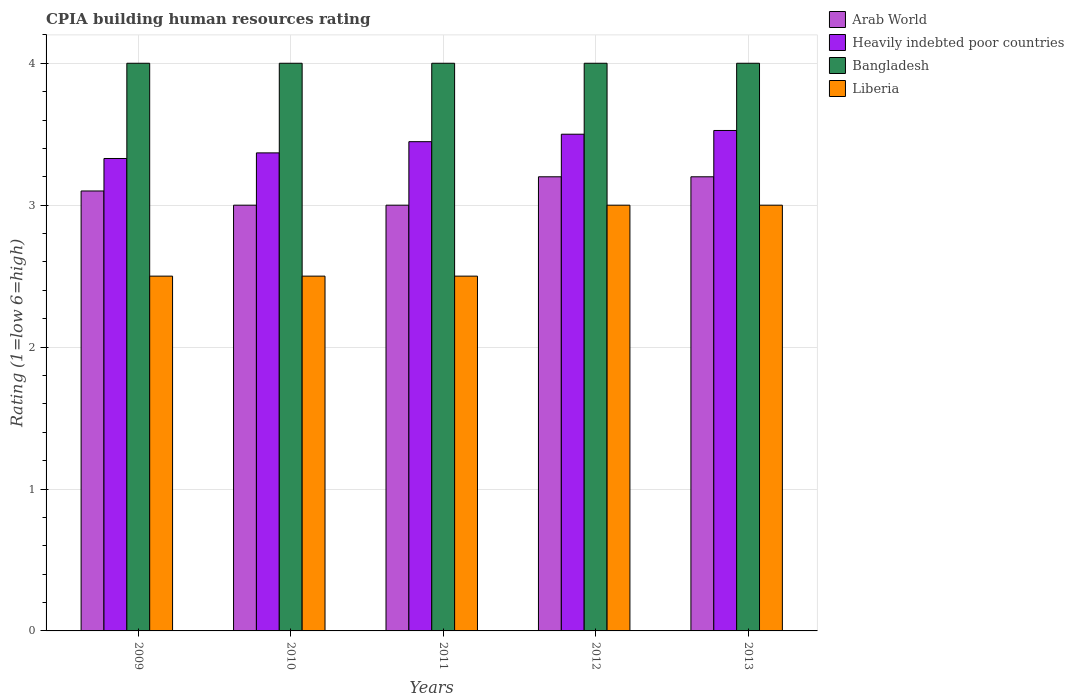How many different coloured bars are there?
Your response must be concise. 4. Are the number of bars per tick equal to the number of legend labels?
Provide a short and direct response. Yes. How many bars are there on the 2nd tick from the left?
Provide a short and direct response. 4. In how many cases, is the number of bars for a given year not equal to the number of legend labels?
Provide a short and direct response. 0. What is the CPIA rating in Bangladesh in 2013?
Ensure brevity in your answer.  4. Across all years, what is the maximum CPIA rating in Bangladesh?
Keep it short and to the point. 4. Across all years, what is the minimum CPIA rating in Heavily indebted poor countries?
Your answer should be very brief. 3.33. What is the total CPIA rating in Arab World in the graph?
Offer a very short reply. 15.5. What is the difference between the CPIA rating in Arab World in 2012 and the CPIA rating in Heavily indebted poor countries in 2013?
Offer a terse response. -0.33. In the year 2013, what is the difference between the CPIA rating in Arab World and CPIA rating in Heavily indebted poor countries?
Your answer should be very brief. -0.33. In how many years, is the CPIA rating in Liberia greater than 1.4?
Give a very brief answer. 5. What is the ratio of the CPIA rating in Heavily indebted poor countries in 2009 to that in 2013?
Your answer should be compact. 0.94. In how many years, is the CPIA rating in Arab World greater than the average CPIA rating in Arab World taken over all years?
Offer a very short reply. 2. Is the sum of the CPIA rating in Bangladesh in 2009 and 2011 greater than the maximum CPIA rating in Heavily indebted poor countries across all years?
Ensure brevity in your answer.  Yes. Is it the case that in every year, the sum of the CPIA rating in Heavily indebted poor countries and CPIA rating in Bangladesh is greater than the sum of CPIA rating in Liberia and CPIA rating in Arab World?
Provide a succinct answer. Yes. What does the 3rd bar from the right in 2012 represents?
Your response must be concise. Heavily indebted poor countries. Is it the case that in every year, the sum of the CPIA rating in Arab World and CPIA rating in Heavily indebted poor countries is greater than the CPIA rating in Liberia?
Make the answer very short. Yes. How many bars are there?
Offer a very short reply. 20. How many years are there in the graph?
Offer a terse response. 5. What is the difference between two consecutive major ticks on the Y-axis?
Give a very brief answer. 1. Are the values on the major ticks of Y-axis written in scientific E-notation?
Give a very brief answer. No. Does the graph contain grids?
Your answer should be compact. Yes. How many legend labels are there?
Offer a very short reply. 4. What is the title of the graph?
Keep it short and to the point. CPIA building human resources rating. Does "United Arab Emirates" appear as one of the legend labels in the graph?
Ensure brevity in your answer.  No. What is the label or title of the X-axis?
Your answer should be very brief. Years. What is the label or title of the Y-axis?
Your answer should be very brief. Rating (1=low 6=high). What is the Rating (1=low 6=high) in Heavily indebted poor countries in 2009?
Ensure brevity in your answer.  3.33. What is the Rating (1=low 6=high) in Arab World in 2010?
Your answer should be compact. 3. What is the Rating (1=low 6=high) of Heavily indebted poor countries in 2010?
Your answer should be very brief. 3.37. What is the Rating (1=low 6=high) of Heavily indebted poor countries in 2011?
Ensure brevity in your answer.  3.45. What is the Rating (1=low 6=high) of Liberia in 2011?
Keep it short and to the point. 2.5. What is the Rating (1=low 6=high) of Heavily indebted poor countries in 2012?
Your answer should be compact. 3.5. What is the Rating (1=low 6=high) of Liberia in 2012?
Your answer should be compact. 3. What is the Rating (1=low 6=high) in Heavily indebted poor countries in 2013?
Your answer should be very brief. 3.53. What is the Rating (1=low 6=high) of Bangladesh in 2013?
Provide a succinct answer. 4. What is the Rating (1=low 6=high) of Liberia in 2013?
Offer a very short reply. 3. Across all years, what is the maximum Rating (1=low 6=high) of Heavily indebted poor countries?
Ensure brevity in your answer.  3.53. Across all years, what is the maximum Rating (1=low 6=high) in Liberia?
Your response must be concise. 3. Across all years, what is the minimum Rating (1=low 6=high) in Arab World?
Give a very brief answer. 3. Across all years, what is the minimum Rating (1=low 6=high) of Heavily indebted poor countries?
Keep it short and to the point. 3.33. Across all years, what is the minimum Rating (1=low 6=high) of Bangladesh?
Your response must be concise. 4. What is the total Rating (1=low 6=high) in Arab World in the graph?
Ensure brevity in your answer.  15.5. What is the total Rating (1=low 6=high) in Heavily indebted poor countries in the graph?
Offer a very short reply. 17.17. What is the difference between the Rating (1=low 6=high) in Heavily indebted poor countries in 2009 and that in 2010?
Keep it short and to the point. -0.04. What is the difference between the Rating (1=low 6=high) of Liberia in 2009 and that in 2010?
Your answer should be compact. 0. What is the difference between the Rating (1=low 6=high) of Arab World in 2009 and that in 2011?
Your response must be concise. 0.1. What is the difference between the Rating (1=low 6=high) in Heavily indebted poor countries in 2009 and that in 2011?
Make the answer very short. -0.12. What is the difference between the Rating (1=low 6=high) of Arab World in 2009 and that in 2012?
Make the answer very short. -0.1. What is the difference between the Rating (1=low 6=high) of Heavily indebted poor countries in 2009 and that in 2012?
Ensure brevity in your answer.  -0.17. What is the difference between the Rating (1=low 6=high) of Bangladesh in 2009 and that in 2012?
Your response must be concise. 0. What is the difference between the Rating (1=low 6=high) in Liberia in 2009 and that in 2012?
Provide a short and direct response. -0.5. What is the difference between the Rating (1=low 6=high) of Arab World in 2009 and that in 2013?
Ensure brevity in your answer.  -0.1. What is the difference between the Rating (1=low 6=high) in Heavily indebted poor countries in 2009 and that in 2013?
Provide a succinct answer. -0.2. What is the difference between the Rating (1=low 6=high) of Liberia in 2009 and that in 2013?
Your response must be concise. -0.5. What is the difference between the Rating (1=low 6=high) in Heavily indebted poor countries in 2010 and that in 2011?
Offer a terse response. -0.08. What is the difference between the Rating (1=low 6=high) of Bangladesh in 2010 and that in 2011?
Keep it short and to the point. 0. What is the difference between the Rating (1=low 6=high) of Arab World in 2010 and that in 2012?
Your response must be concise. -0.2. What is the difference between the Rating (1=low 6=high) of Heavily indebted poor countries in 2010 and that in 2012?
Your answer should be very brief. -0.13. What is the difference between the Rating (1=low 6=high) of Bangladesh in 2010 and that in 2012?
Keep it short and to the point. 0. What is the difference between the Rating (1=low 6=high) of Liberia in 2010 and that in 2012?
Your response must be concise. -0.5. What is the difference between the Rating (1=low 6=high) of Heavily indebted poor countries in 2010 and that in 2013?
Ensure brevity in your answer.  -0.16. What is the difference between the Rating (1=low 6=high) in Bangladesh in 2010 and that in 2013?
Offer a terse response. 0. What is the difference between the Rating (1=low 6=high) in Arab World in 2011 and that in 2012?
Your answer should be compact. -0.2. What is the difference between the Rating (1=low 6=high) of Heavily indebted poor countries in 2011 and that in 2012?
Offer a terse response. -0.05. What is the difference between the Rating (1=low 6=high) in Arab World in 2011 and that in 2013?
Your response must be concise. -0.2. What is the difference between the Rating (1=low 6=high) of Heavily indebted poor countries in 2011 and that in 2013?
Your answer should be compact. -0.08. What is the difference between the Rating (1=low 6=high) of Bangladesh in 2011 and that in 2013?
Your response must be concise. 0. What is the difference between the Rating (1=low 6=high) of Liberia in 2011 and that in 2013?
Keep it short and to the point. -0.5. What is the difference between the Rating (1=low 6=high) in Heavily indebted poor countries in 2012 and that in 2013?
Give a very brief answer. -0.03. What is the difference between the Rating (1=low 6=high) in Arab World in 2009 and the Rating (1=low 6=high) in Heavily indebted poor countries in 2010?
Keep it short and to the point. -0.27. What is the difference between the Rating (1=low 6=high) of Arab World in 2009 and the Rating (1=low 6=high) of Bangladesh in 2010?
Your answer should be very brief. -0.9. What is the difference between the Rating (1=low 6=high) of Heavily indebted poor countries in 2009 and the Rating (1=low 6=high) of Bangladesh in 2010?
Offer a very short reply. -0.67. What is the difference between the Rating (1=low 6=high) in Heavily indebted poor countries in 2009 and the Rating (1=low 6=high) in Liberia in 2010?
Your answer should be very brief. 0.83. What is the difference between the Rating (1=low 6=high) of Bangladesh in 2009 and the Rating (1=low 6=high) of Liberia in 2010?
Ensure brevity in your answer.  1.5. What is the difference between the Rating (1=low 6=high) of Arab World in 2009 and the Rating (1=low 6=high) of Heavily indebted poor countries in 2011?
Give a very brief answer. -0.35. What is the difference between the Rating (1=low 6=high) in Arab World in 2009 and the Rating (1=low 6=high) in Bangladesh in 2011?
Offer a very short reply. -0.9. What is the difference between the Rating (1=low 6=high) of Arab World in 2009 and the Rating (1=low 6=high) of Liberia in 2011?
Your answer should be compact. 0.6. What is the difference between the Rating (1=low 6=high) in Heavily indebted poor countries in 2009 and the Rating (1=low 6=high) in Bangladesh in 2011?
Ensure brevity in your answer.  -0.67. What is the difference between the Rating (1=low 6=high) in Heavily indebted poor countries in 2009 and the Rating (1=low 6=high) in Liberia in 2011?
Your answer should be compact. 0.83. What is the difference between the Rating (1=low 6=high) in Arab World in 2009 and the Rating (1=low 6=high) in Bangladesh in 2012?
Offer a very short reply. -0.9. What is the difference between the Rating (1=low 6=high) in Arab World in 2009 and the Rating (1=low 6=high) in Liberia in 2012?
Your response must be concise. 0.1. What is the difference between the Rating (1=low 6=high) of Heavily indebted poor countries in 2009 and the Rating (1=low 6=high) of Bangladesh in 2012?
Provide a short and direct response. -0.67. What is the difference between the Rating (1=low 6=high) in Heavily indebted poor countries in 2009 and the Rating (1=low 6=high) in Liberia in 2012?
Make the answer very short. 0.33. What is the difference between the Rating (1=low 6=high) in Bangladesh in 2009 and the Rating (1=low 6=high) in Liberia in 2012?
Offer a very short reply. 1. What is the difference between the Rating (1=low 6=high) of Arab World in 2009 and the Rating (1=low 6=high) of Heavily indebted poor countries in 2013?
Give a very brief answer. -0.43. What is the difference between the Rating (1=low 6=high) of Arab World in 2009 and the Rating (1=low 6=high) of Liberia in 2013?
Offer a very short reply. 0.1. What is the difference between the Rating (1=low 6=high) of Heavily indebted poor countries in 2009 and the Rating (1=low 6=high) of Bangladesh in 2013?
Offer a terse response. -0.67. What is the difference between the Rating (1=low 6=high) in Heavily indebted poor countries in 2009 and the Rating (1=low 6=high) in Liberia in 2013?
Give a very brief answer. 0.33. What is the difference between the Rating (1=low 6=high) in Bangladesh in 2009 and the Rating (1=low 6=high) in Liberia in 2013?
Ensure brevity in your answer.  1. What is the difference between the Rating (1=low 6=high) of Arab World in 2010 and the Rating (1=low 6=high) of Heavily indebted poor countries in 2011?
Provide a short and direct response. -0.45. What is the difference between the Rating (1=low 6=high) of Heavily indebted poor countries in 2010 and the Rating (1=low 6=high) of Bangladesh in 2011?
Keep it short and to the point. -0.63. What is the difference between the Rating (1=low 6=high) in Heavily indebted poor countries in 2010 and the Rating (1=low 6=high) in Liberia in 2011?
Keep it short and to the point. 0.87. What is the difference between the Rating (1=low 6=high) in Arab World in 2010 and the Rating (1=low 6=high) in Heavily indebted poor countries in 2012?
Your response must be concise. -0.5. What is the difference between the Rating (1=low 6=high) of Arab World in 2010 and the Rating (1=low 6=high) of Liberia in 2012?
Offer a very short reply. 0. What is the difference between the Rating (1=low 6=high) in Heavily indebted poor countries in 2010 and the Rating (1=low 6=high) in Bangladesh in 2012?
Provide a succinct answer. -0.63. What is the difference between the Rating (1=low 6=high) of Heavily indebted poor countries in 2010 and the Rating (1=low 6=high) of Liberia in 2012?
Provide a short and direct response. 0.37. What is the difference between the Rating (1=low 6=high) of Bangladesh in 2010 and the Rating (1=low 6=high) of Liberia in 2012?
Offer a very short reply. 1. What is the difference between the Rating (1=low 6=high) in Arab World in 2010 and the Rating (1=low 6=high) in Heavily indebted poor countries in 2013?
Your response must be concise. -0.53. What is the difference between the Rating (1=low 6=high) in Arab World in 2010 and the Rating (1=low 6=high) in Bangladesh in 2013?
Your answer should be very brief. -1. What is the difference between the Rating (1=low 6=high) in Heavily indebted poor countries in 2010 and the Rating (1=low 6=high) in Bangladesh in 2013?
Make the answer very short. -0.63. What is the difference between the Rating (1=low 6=high) in Heavily indebted poor countries in 2010 and the Rating (1=low 6=high) in Liberia in 2013?
Provide a short and direct response. 0.37. What is the difference between the Rating (1=low 6=high) of Arab World in 2011 and the Rating (1=low 6=high) of Liberia in 2012?
Your response must be concise. 0. What is the difference between the Rating (1=low 6=high) in Heavily indebted poor countries in 2011 and the Rating (1=low 6=high) in Bangladesh in 2012?
Ensure brevity in your answer.  -0.55. What is the difference between the Rating (1=low 6=high) of Heavily indebted poor countries in 2011 and the Rating (1=low 6=high) of Liberia in 2012?
Your response must be concise. 0.45. What is the difference between the Rating (1=low 6=high) in Bangladesh in 2011 and the Rating (1=low 6=high) in Liberia in 2012?
Your response must be concise. 1. What is the difference between the Rating (1=low 6=high) in Arab World in 2011 and the Rating (1=low 6=high) in Heavily indebted poor countries in 2013?
Your response must be concise. -0.53. What is the difference between the Rating (1=low 6=high) of Arab World in 2011 and the Rating (1=low 6=high) of Bangladesh in 2013?
Ensure brevity in your answer.  -1. What is the difference between the Rating (1=low 6=high) in Arab World in 2011 and the Rating (1=low 6=high) in Liberia in 2013?
Ensure brevity in your answer.  0. What is the difference between the Rating (1=low 6=high) in Heavily indebted poor countries in 2011 and the Rating (1=low 6=high) in Bangladesh in 2013?
Provide a short and direct response. -0.55. What is the difference between the Rating (1=low 6=high) of Heavily indebted poor countries in 2011 and the Rating (1=low 6=high) of Liberia in 2013?
Make the answer very short. 0.45. What is the difference between the Rating (1=low 6=high) in Bangladesh in 2011 and the Rating (1=low 6=high) in Liberia in 2013?
Your response must be concise. 1. What is the difference between the Rating (1=low 6=high) of Arab World in 2012 and the Rating (1=low 6=high) of Heavily indebted poor countries in 2013?
Offer a very short reply. -0.33. What is the difference between the Rating (1=low 6=high) of Arab World in 2012 and the Rating (1=low 6=high) of Bangladesh in 2013?
Your answer should be compact. -0.8. What is the difference between the Rating (1=low 6=high) of Heavily indebted poor countries in 2012 and the Rating (1=low 6=high) of Liberia in 2013?
Provide a succinct answer. 0.5. What is the average Rating (1=low 6=high) in Heavily indebted poor countries per year?
Offer a very short reply. 3.43. In the year 2009, what is the difference between the Rating (1=low 6=high) of Arab World and Rating (1=low 6=high) of Heavily indebted poor countries?
Your answer should be very brief. -0.23. In the year 2009, what is the difference between the Rating (1=low 6=high) of Arab World and Rating (1=low 6=high) of Bangladesh?
Offer a terse response. -0.9. In the year 2009, what is the difference between the Rating (1=low 6=high) in Arab World and Rating (1=low 6=high) in Liberia?
Offer a terse response. 0.6. In the year 2009, what is the difference between the Rating (1=low 6=high) in Heavily indebted poor countries and Rating (1=low 6=high) in Bangladesh?
Your response must be concise. -0.67. In the year 2009, what is the difference between the Rating (1=low 6=high) in Heavily indebted poor countries and Rating (1=low 6=high) in Liberia?
Offer a very short reply. 0.83. In the year 2009, what is the difference between the Rating (1=low 6=high) in Bangladesh and Rating (1=low 6=high) in Liberia?
Provide a short and direct response. 1.5. In the year 2010, what is the difference between the Rating (1=low 6=high) in Arab World and Rating (1=low 6=high) in Heavily indebted poor countries?
Offer a terse response. -0.37. In the year 2010, what is the difference between the Rating (1=low 6=high) of Arab World and Rating (1=low 6=high) of Bangladesh?
Offer a terse response. -1. In the year 2010, what is the difference between the Rating (1=low 6=high) in Arab World and Rating (1=low 6=high) in Liberia?
Offer a terse response. 0.5. In the year 2010, what is the difference between the Rating (1=low 6=high) of Heavily indebted poor countries and Rating (1=low 6=high) of Bangladesh?
Give a very brief answer. -0.63. In the year 2010, what is the difference between the Rating (1=low 6=high) in Heavily indebted poor countries and Rating (1=low 6=high) in Liberia?
Your response must be concise. 0.87. In the year 2011, what is the difference between the Rating (1=low 6=high) of Arab World and Rating (1=low 6=high) of Heavily indebted poor countries?
Offer a terse response. -0.45. In the year 2011, what is the difference between the Rating (1=low 6=high) in Arab World and Rating (1=low 6=high) in Bangladesh?
Ensure brevity in your answer.  -1. In the year 2011, what is the difference between the Rating (1=low 6=high) in Arab World and Rating (1=low 6=high) in Liberia?
Your response must be concise. 0.5. In the year 2011, what is the difference between the Rating (1=low 6=high) in Heavily indebted poor countries and Rating (1=low 6=high) in Bangladesh?
Provide a succinct answer. -0.55. In the year 2011, what is the difference between the Rating (1=low 6=high) in Heavily indebted poor countries and Rating (1=low 6=high) in Liberia?
Ensure brevity in your answer.  0.95. In the year 2012, what is the difference between the Rating (1=low 6=high) of Arab World and Rating (1=low 6=high) of Heavily indebted poor countries?
Provide a succinct answer. -0.3. In the year 2012, what is the difference between the Rating (1=low 6=high) in Arab World and Rating (1=low 6=high) in Liberia?
Keep it short and to the point. 0.2. In the year 2012, what is the difference between the Rating (1=low 6=high) in Heavily indebted poor countries and Rating (1=low 6=high) in Liberia?
Ensure brevity in your answer.  0.5. In the year 2012, what is the difference between the Rating (1=low 6=high) in Bangladesh and Rating (1=low 6=high) in Liberia?
Offer a terse response. 1. In the year 2013, what is the difference between the Rating (1=low 6=high) in Arab World and Rating (1=low 6=high) in Heavily indebted poor countries?
Provide a short and direct response. -0.33. In the year 2013, what is the difference between the Rating (1=low 6=high) of Arab World and Rating (1=low 6=high) of Bangladesh?
Your answer should be very brief. -0.8. In the year 2013, what is the difference between the Rating (1=low 6=high) in Arab World and Rating (1=low 6=high) in Liberia?
Your response must be concise. 0.2. In the year 2013, what is the difference between the Rating (1=low 6=high) of Heavily indebted poor countries and Rating (1=low 6=high) of Bangladesh?
Offer a very short reply. -0.47. In the year 2013, what is the difference between the Rating (1=low 6=high) of Heavily indebted poor countries and Rating (1=low 6=high) of Liberia?
Ensure brevity in your answer.  0.53. What is the ratio of the Rating (1=low 6=high) in Heavily indebted poor countries in 2009 to that in 2010?
Offer a very short reply. 0.99. What is the ratio of the Rating (1=low 6=high) of Bangladesh in 2009 to that in 2010?
Keep it short and to the point. 1. What is the ratio of the Rating (1=low 6=high) in Liberia in 2009 to that in 2010?
Your answer should be very brief. 1. What is the ratio of the Rating (1=low 6=high) in Arab World in 2009 to that in 2011?
Your response must be concise. 1.03. What is the ratio of the Rating (1=low 6=high) in Heavily indebted poor countries in 2009 to that in 2011?
Offer a very short reply. 0.97. What is the ratio of the Rating (1=low 6=high) of Arab World in 2009 to that in 2012?
Provide a succinct answer. 0.97. What is the ratio of the Rating (1=low 6=high) of Heavily indebted poor countries in 2009 to that in 2012?
Your response must be concise. 0.95. What is the ratio of the Rating (1=low 6=high) of Arab World in 2009 to that in 2013?
Your response must be concise. 0.97. What is the ratio of the Rating (1=low 6=high) of Heavily indebted poor countries in 2009 to that in 2013?
Your answer should be very brief. 0.94. What is the ratio of the Rating (1=low 6=high) of Arab World in 2010 to that in 2011?
Provide a short and direct response. 1. What is the ratio of the Rating (1=low 6=high) in Heavily indebted poor countries in 2010 to that in 2011?
Make the answer very short. 0.98. What is the ratio of the Rating (1=low 6=high) of Arab World in 2010 to that in 2012?
Provide a succinct answer. 0.94. What is the ratio of the Rating (1=low 6=high) of Heavily indebted poor countries in 2010 to that in 2012?
Give a very brief answer. 0.96. What is the ratio of the Rating (1=low 6=high) in Liberia in 2010 to that in 2012?
Keep it short and to the point. 0.83. What is the ratio of the Rating (1=low 6=high) of Arab World in 2010 to that in 2013?
Your answer should be very brief. 0.94. What is the ratio of the Rating (1=low 6=high) of Heavily indebted poor countries in 2010 to that in 2013?
Provide a short and direct response. 0.96. What is the ratio of the Rating (1=low 6=high) in Liberia in 2010 to that in 2013?
Your answer should be compact. 0.83. What is the ratio of the Rating (1=low 6=high) in Arab World in 2011 to that in 2012?
Offer a terse response. 0.94. What is the ratio of the Rating (1=low 6=high) of Bangladesh in 2011 to that in 2012?
Your response must be concise. 1. What is the ratio of the Rating (1=low 6=high) in Liberia in 2011 to that in 2012?
Your response must be concise. 0.83. What is the ratio of the Rating (1=low 6=high) in Heavily indebted poor countries in 2011 to that in 2013?
Ensure brevity in your answer.  0.98. What is the ratio of the Rating (1=low 6=high) of Bangladesh in 2011 to that in 2013?
Your answer should be compact. 1. What is the ratio of the Rating (1=low 6=high) of Liberia in 2011 to that in 2013?
Provide a short and direct response. 0.83. What is the ratio of the Rating (1=low 6=high) of Arab World in 2012 to that in 2013?
Give a very brief answer. 1. What is the ratio of the Rating (1=low 6=high) of Liberia in 2012 to that in 2013?
Your answer should be compact. 1. What is the difference between the highest and the second highest Rating (1=low 6=high) in Heavily indebted poor countries?
Keep it short and to the point. 0.03. What is the difference between the highest and the second highest Rating (1=low 6=high) in Liberia?
Give a very brief answer. 0. What is the difference between the highest and the lowest Rating (1=low 6=high) of Arab World?
Keep it short and to the point. 0.2. What is the difference between the highest and the lowest Rating (1=low 6=high) of Heavily indebted poor countries?
Make the answer very short. 0.2. 